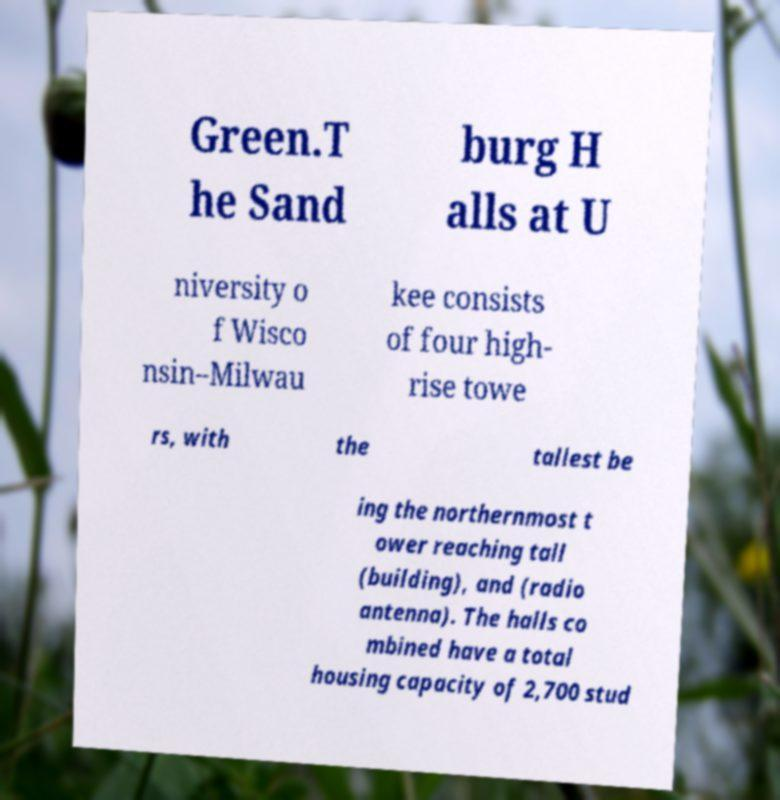Please read and relay the text visible in this image. What does it say? Green.T he Sand burg H alls at U niversity o f Wisco nsin–Milwau kee consists of four high- rise towe rs, with the tallest be ing the northernmost t ower reaching tall (building), and (radio antenna). The halls co mbined have a total housing capacity of 2,700 stud 